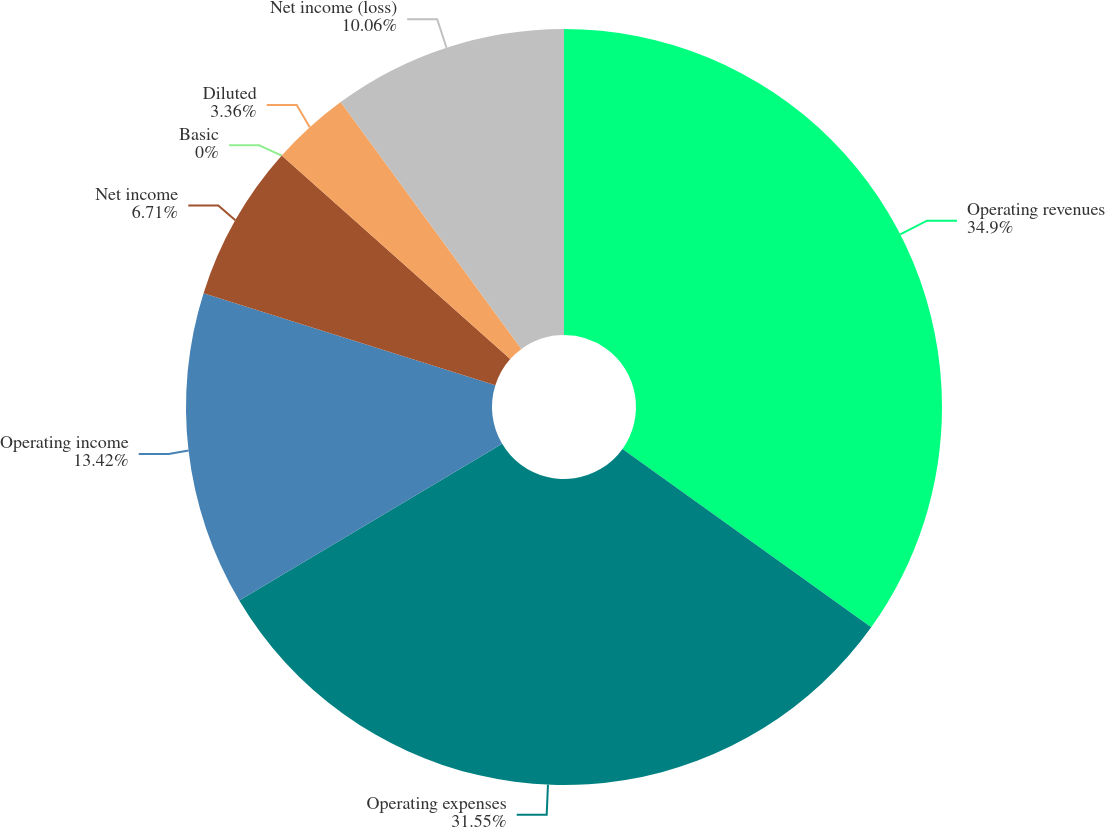<chart> <loc_0><loc_0><loc_500><loc_500><pie_chart><fcel>Operating revenues<fcel>Operating expenses<fcel>Operating income<fcel>Net income<fcel>Basic<fcel>Diluted<fcel>Net income (loss)<nl><fcel>34.9%<fcel>31.55%<fcel>13.42%<fcel>6.71%<fcel>0.0%<fcel>3.36%<fcel>10.06%<nl></chart> 